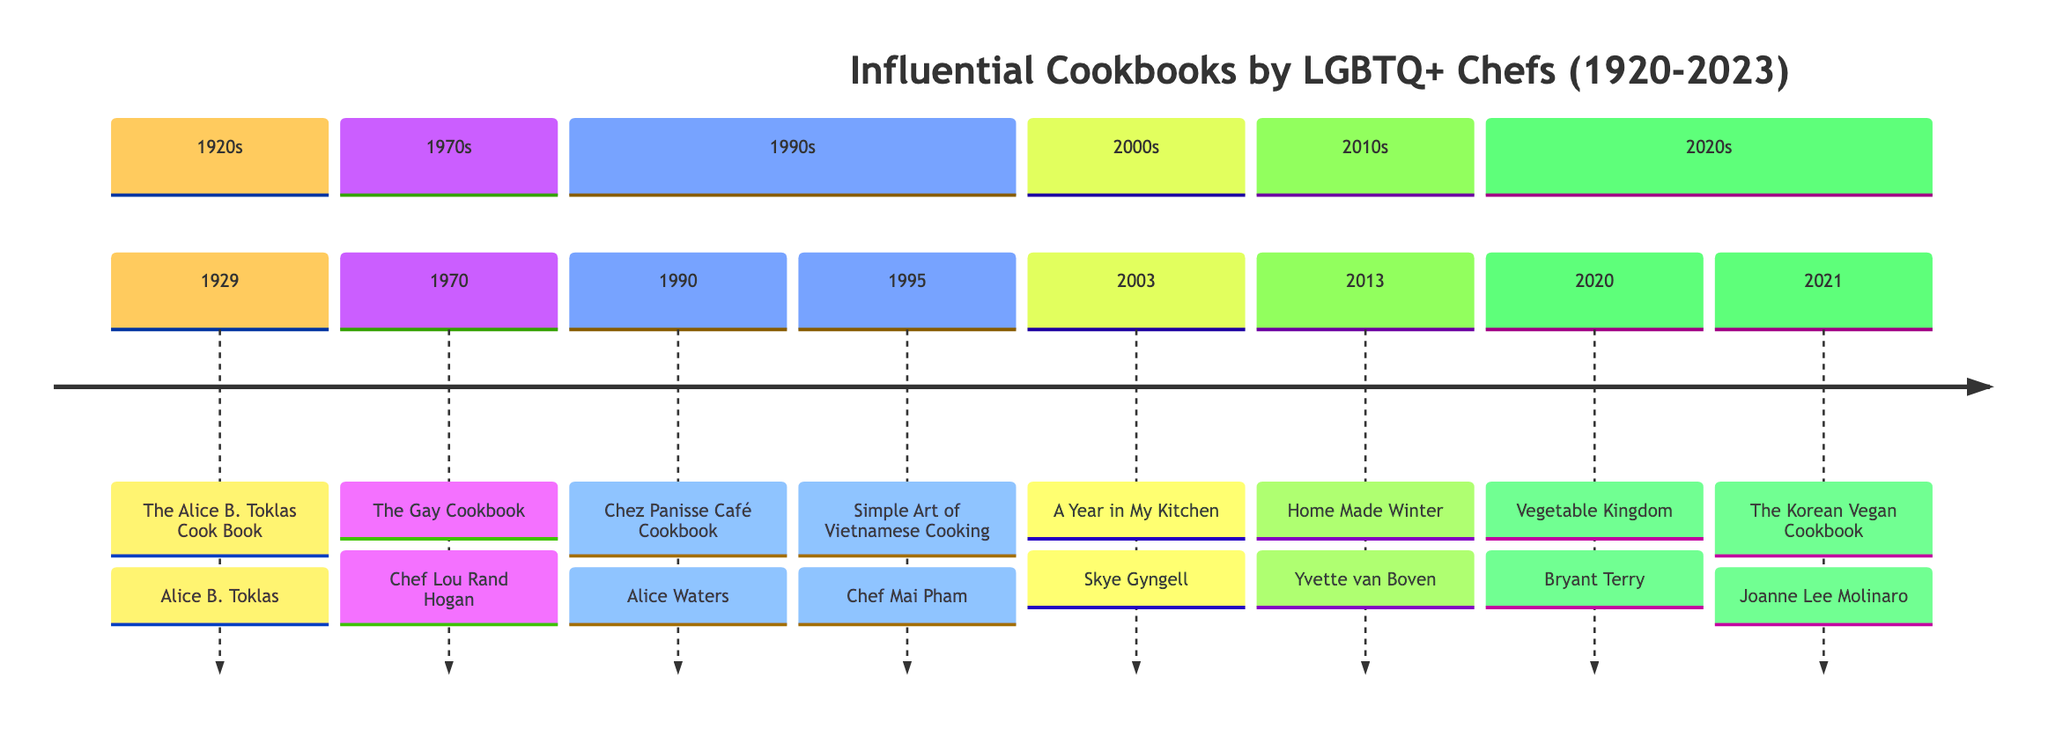What is the title of the first cookbook listed in the timeline? The timeline displays various cookbooks along with their publication years. The first event in the timeline is from 1929, and the corresponding title is 'The Alice B. Toklas Cook Book'.
Answer: The Alice B. Toklas Cook Book Who authored 'The Gay Cookbook'? The event in 1970 is explicitly linked to 'The Gay Cookbook', which is authored by Chef Lou Rand Hogan.
Answer: Chef Lou Rand Hogan How many cookbooks are listed for the 1990s? The timeline indicates two events occurring in the 1990s: one in 1990 ('Chez Panisse Café Cookbook' by Alice Waters) and another in 1995 ('Simple Art of Vietnamese Cooking' by Chef Mai Pham), thus making it a total of two cookbooks.
Answer: 2 Which cookbook was published in 2003? The timeline event for the year 2003 specifies the publication of 'A Year in My Kitchen' by Skye Gyngell.
Answer: A Year in My Kitchen Who is identified as an openly LGBTQ+ chef in the timeline? By reviewing the events in the timeline, 'Home Made Winter' by Yvette van Boven (2013) and 'Simple Art of Vietnamese Cooking' by Chef Mai Pham (1995) are specifically noted as being authored by openly LGBTQ+ chefs, marking them as examples.
Answer: Yvette van Boven What significant contribution does Alice Waters make, according to the timeline? The timeline mentions that although Alice Waters does not explicitly identify as LGBTQ+, she has been considered an important ally to the community. This contribution is significant in the context of support rather than direct identification.
Answer: Important ally In which year was 'Vegetable Kingdom' published? According to the timeline, the cookbook 'Vegetable Kingdom: The Abundant World of Vegan Recipes' was published in 2020, as indicated in the corresponding event.
Answer: 2020 What is the theme of 'The Korean Vegan Cookbook'? The event for 'The Korean Vegan Cookbook' by Joanne Lee Molinaro (2021) indicates that the theme revolves around exploring Korean cuisine through a vegan lens, highlighting its focus on plant-based recipes.
Answer: Exploring Korean cuisine through a vegan lens 